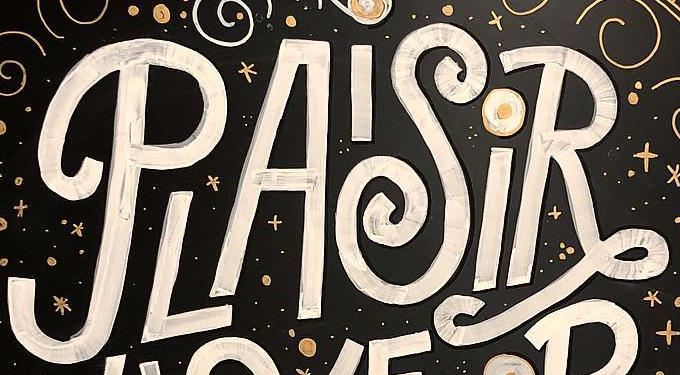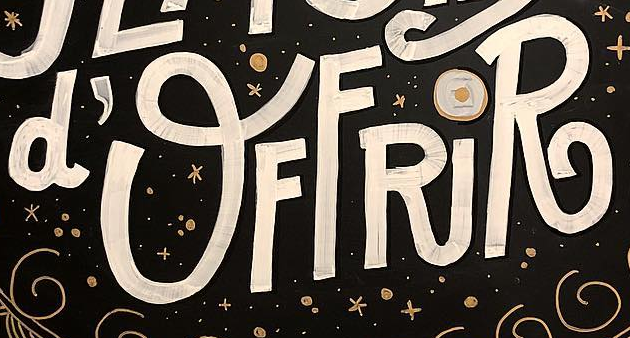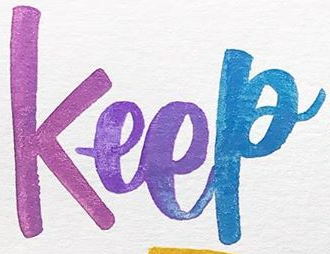What text appears in these images from left to right, separated by a semicolon? PLAISiR; d'OFFRiR; Keep 